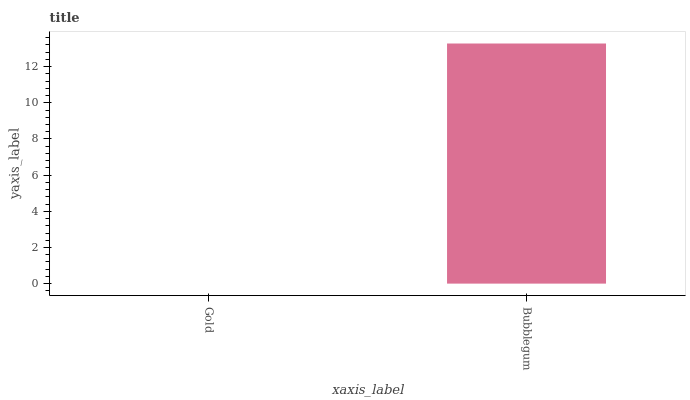Is Gold the minimum?
Answer yes or no. Yes. Is Bubblegum the maximum?
Answer yes or no. Yes. Is Bubblegum the minimum?
Answer yes or no. No. Is Bubblegum greater than Gold?
Answer yes or no. Yes. Is Gold less than Bubblegum?
Answer yes or no. Yes. Is Gold greater than Bubblegum?
Answer yes or no. No. Is Bubblegum less than Gold?
Answer yes or no. No. Is Bubblegum the high median?
Answer yes or no. Yes. Is Gold the low median?
Answer yes or no. Yes. Is Gold the high median?
Answer yes or no. No. Is Bubblegum the low median?
Answer yes or no. No. 